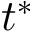<formula> <loc_0><loc_0><loc_500><loc_500>t ^ { \ast }</formula> 